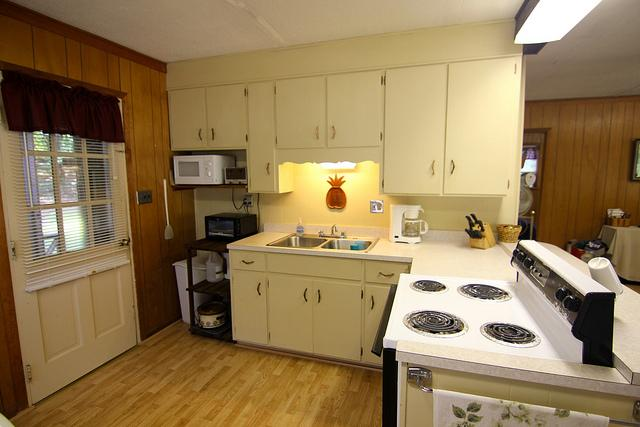How is the kitchen counter by the stove illuminated? Please explain your reasoning. fluorescent light. There is a light up above the sink. 